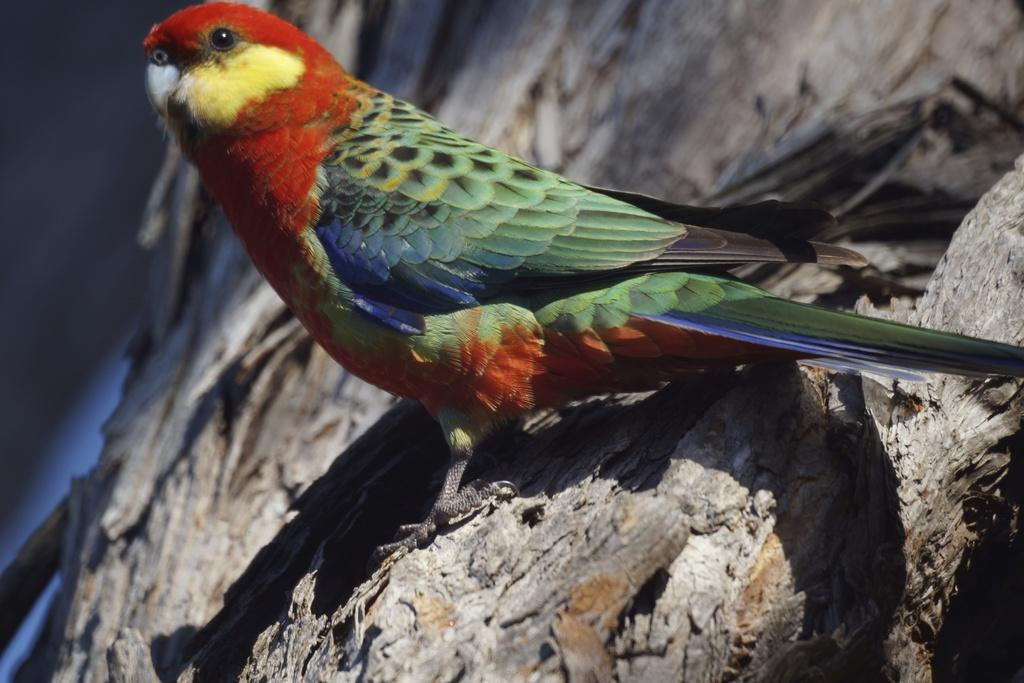What type of animal can be seen in the image? There is a bird in the image. Where is the bird located in the image? The bird is on the branch of a tree. How many snails are crawling on the branch with the bird in the image? There are no snails visible in the image; only the bird is present on the branch. What type of bead is hanging from the bird's beak in the image? There is no bead present in the image; the bird is not holding or wearing any beads. 